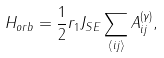Convert formula to latex. <formula><loc_0><loc_0><loc_500><loc_500>H _ { o r b } = \frac { 1 } { 2 } r _ { 1 } J _ { S E } \sum _ { \langle i j \rangle } A _ { i j } ^ { ( \gamma ) } ,</formula> 